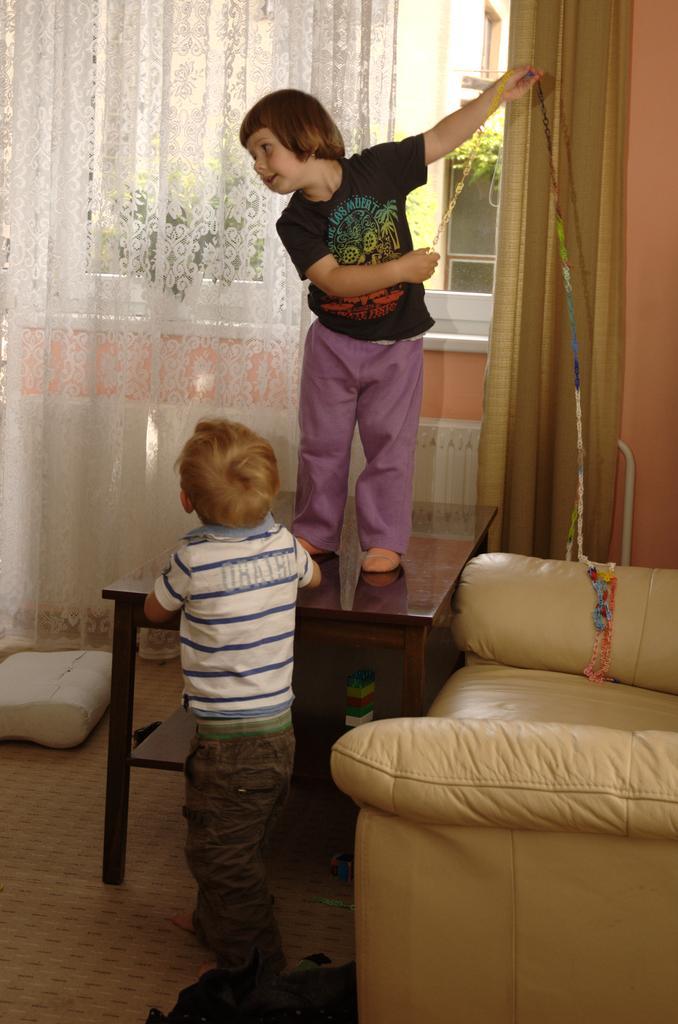In one or two sentences, can you explain what this image depicts? As we can see in the image there is a window, curtain, sofa and two people. 